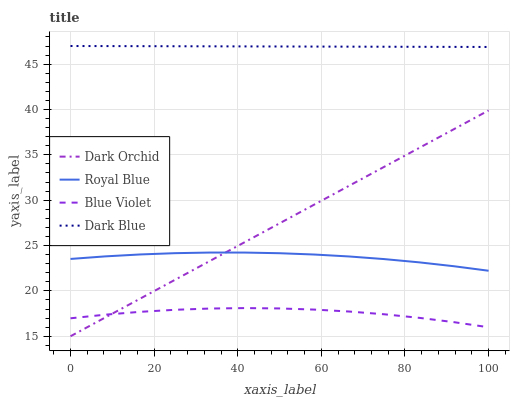Does Blue Violet have the minimum area under the curve?
Answer yes or no. Yes. Does Dark Blue have the maximum area under the curve?
Answer yes or no. Yes. Does Dark Orchid have the minimum area under the curve?
Answer yes or no. No. Does Dark Orchid have the maximum area under the curve?
Answer yes or no. No. Is Dark Orchid the smoothest?
Answer yes or no. Yes. Is Blue Violet the roughest?
Answer yes or no. Yes. Is Blue Violet the smoothest?
Answer yes or no. No. Is Dark Orchid the roughest?
Answer yes or no. No. Does Dark Orchid have the lowest value?
Answer yes or no. Yes. Does Blue Violet have the lowest value?
Answer yes or no. No. Does Dark Blue have the highest value?
Answer yes or no. Yes. Does Dark Orchid have the highest value?
Answer yes or no. No. Is Blue Violet less than Dark Blue?
Answer yes or no. Yes. Is Dark Blue greater than Royal Blue?
Answer yes or no. Yes. Does Dark Orchid intersect Royal Blue?
Answer yes or no. Yes. Is Dark Orchid less than Royal Blue?
Answer yes or no. No. Is Dark Orchid greater than Royal Blue?
Answer yes or no. No. Does Blue Violet intersect Dark Blue?
Answer yes or no. No. 